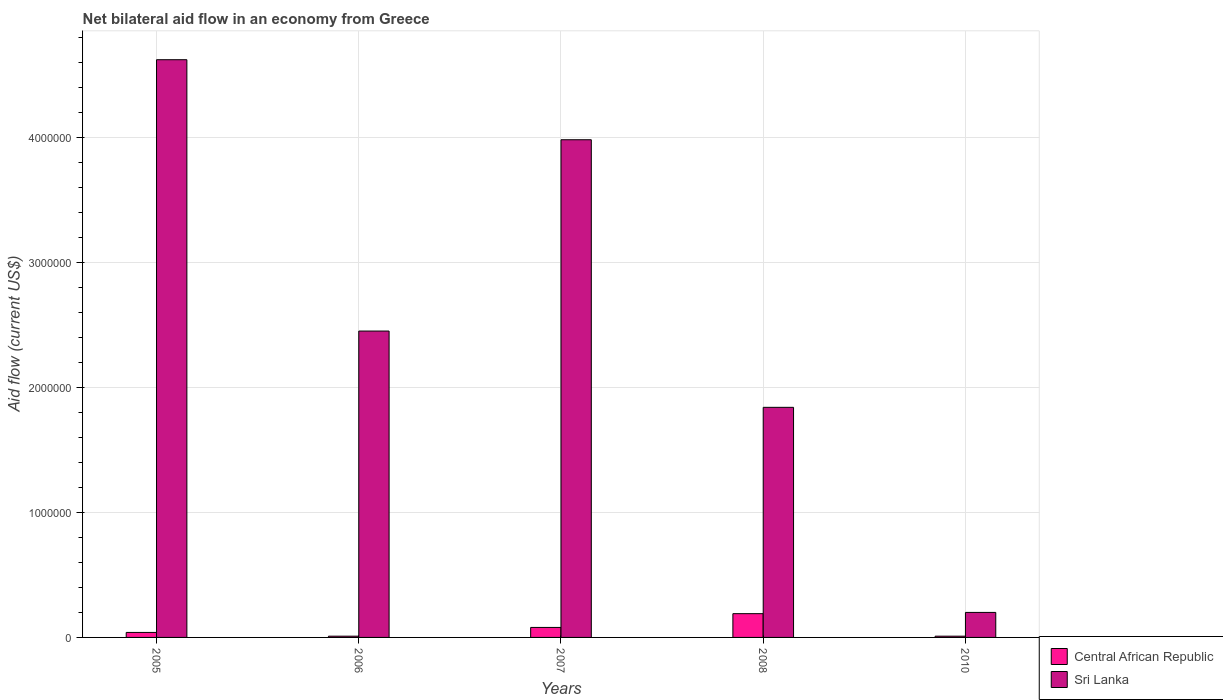How many different coloured bars are there?
Provide a succinct answer. 2. How many groups of bars are there?
Provide a succinct answer. 5. Are the number of bars per tick equal to the number of legend labels?
Keep it short and to the point. Yes. How many bars are there on the 4th tick from the right?
Offer a very short reply. 2. What is the label of the 2nd group of bars from the left?
Make the answer very short. 2006. Across all years, what is the minimum net bilateral aid flow in Central African Republic?
Ensure brevity in your answer.  10000. In which year was the net bilateral aid flow in Sri Lanka maximum?
Your answer should be compact. 2005. In which year was the net bilateral aid flow in Central African Republic minimum?
Keep it short and to the point. 2006. What is the total net bilateral aid flow in Sri Lanka in the graph?
Give a very brief answer. 1.31e+07. What is the difference between the net bilateral aid flow in Central African Republic in 2005 and that in 2008?
Make the answer very short. -1.50e+05. What is the average net bilateral aid flow in Central African Republic per year?
Ensure brevity in your answer.  6.60e+04. In the year 2007, what is the difference between the net bilateral aid flow in Sri Lanka and net bilateral aid flow in Central African Republic?
Make the answer very short. 3.90e+06. What is the difference between the highest and the second highest net bilateral aid flow in Sri Lanka?
Your answer should be very brief. 6.40e+05. In how many years, is the net bilateral aid flow in Sri Lanka greater than the average net bilateral aid flow in Sri Lanka taken over all years?
Provide a short and direct response. 2. What does the 1st bar from the left in 2008 represents?
Ensure brevity in your answer.  Central African Republic. What does the 1st bar from the right in 2006 represents?
Your answer should be very brief. Sri Lanka. How many bars are there?
Your answer should be compact. 10. What is the difference between two consecutive major ticks on the Y-axis?
Provide a succinct answer. 1.00e+06. Are the values on the major ticks of Y-axis written in scientific E-notation?
Keep it short and to the point. No. How many legend labels are there?
Make the answer very short. 2. What is the title of the graph?
Keep it short and to the point. Net bilateral aid flow in an economy from Greece. Does "Ireland" appear as one of the legend labels in the graph?
Offer a very short reply. No. What is the Aid flow (current US$) of Central African Republic in 2005?
Offer a very short reply. 4.00e+04. What is the Aid flow (current US$) of Sri Lanka in 2005?
Offer a terse response. 4.62e+06. What is the Aid flow (current US$) of Central African Republic in 2006?
Provide a succinct answer. 10000. What is the Aid flow (current US$) of Sri Lanka in 2006?
Your response must be concise. 2.45e+06. What is the Aid flow (current US$) of Central African Republic in 2007?
Your response must be concise. 8.00e+04. What is the Aid flow (current US$) of Sri Lanka in 2007?
Make the answer very short. 3.98e+06. What is the Aid flow (current US$) in Central African Republic in 2008?
Ensure brevity in your answer.  1.90e+05. What is the Aid flow (current US$) of Sri Lanka in 2008?
Offer a terse response. 1.84e+06. What is the Aid flow (current US$) in Sri Lanka in 2010?
Provide a short and direct response. 2.00e+05. Across all years, what is the maximum Aid flow (current US$) in Central African Republic?
Offer a terse response. 1.90e+05. Across all years, what is the maximum Aid flow (current US$) of Sri Lanka?
Provide a short and direct response. 4.62e+06. What is the total Aid flow (current US$) in Sri Lanka in the graph?
Offer a terse response. 1.31e+07. What is the difference between the Aid flow (current US$) in Central African Republic in 2005 and that in 2006?
Offer a terse response. 3.00e+04. What is the difference between the Aid flow (current US$) in Sri Lanka in 2005 and that in 2006?
Make the answer very short. 2.17e+06. What is the difference between the Aid flow (current US$) in Central African Republic in 2005 and that in 2007?
Your answer should be very brief. -4.00e+04. What is the difference between the Aid flow (current US$) in Sri Lanka in 2005 and that in 2007?
Keep it short and to the point. 6.40e+05. What is the difference between the Aid flow (current US$) in Sri Lanka in 2005 and that in 2008?
Your response must be concise. 2.78e+06. What is the difference between the Aid flow (current US$) of Central African Republic in 2005 and that in 2010?
Provide a short and direct response. 3.00e+04. What is the difference between the Aid flow (current US$) of Sri Lanka in 2005 and that in 2010?
Your answer should be very brief. 4.42e+06. What is the difference between the Aid flow (current US$) of Sri Lanka in 2006 and that in 2007?
Keep it short and to the point. -1.53e+06. What is the difference between the Aid flow (current US$) of Central African Republic in 2006 and that in 2008?
Offer a terse response. -1.80e+05. What is the difference between the Aid flow (current US$) of Central African Republic in 2006 and that in 2010?
Offer a terse response. 0. What is the difference between the Aid flow (current US$) of Sri Lanka in 2006 and that in 2010?
Your response must be concise. 2.25e+06. What is the difference between the Aid flow (current US$) in Sri Lanka in 2007 and that in 2008?
Provide a succinct answer. 2.14e+06. What is the difference between the Aid flow (current US$) in Central African Republic in 2007 and that in 2010?
Provide a succinct answer. 7.00e+04. What is the difference between the Aid flow (current US$) in Sri Lanka in 2007 and that in 2010?
Give a very brief answer. 3.78e+06. What is the difference between the Aid flow (current US$) in Central African Republic in 2008 and that in 2010?
Provide a succinct answer. 1.80e+05. What is the difference between the Aid flow (current US$) of Sri Lanka in 2008 and that in 2010?
Ensure brevity in your answer.  1.64e+06. What is the difference between the Aid flow (current US$) of Central African Republic in 2005 and the Aid flow (current US$) of Sri Lanka in 2006?
Make the answer very short. -2.41e+06. What is the difference between the Aid flow (current US$) of Central African Republic in 2005 and the Aid flow (current US$) of Sri Lanka in 2007?
Offer a terse response. -3.94e+06. What is the difference between the Aid flow (current US$) in Central African Republic in 2005 and the Aid flow (current US$) in Sri Lanka in 2008?
Ensure brevity in your answer.  -1.80e+06. What is the difference between the Aid flow (current US$) of Central African Republic in 2005 and the Aid flow (current US$) of Sri Lanka in 2010?
Give a very brief answer. -1.60e+05. What is the difference between the Aid flow (current US$) in Central African Republic in 2006 and the Aid flow (current US$) in Sri Lanka in 2007?
Your answer should be very brief. -3.97e+06. What is the difference between the Aid flow (current US$) in Central African Republic in 2006 and the Aid flow (current US$) in Sri Lanka in 2008?
Your answer should be compact. -1.83e+06. What is the difference between the Aid flow (current US$) of Central African Republic in 2006 and the Aid flow (current US$) of Sri Lanka in 2010?
Your answer should be compact. -1.90e+05. What is the difference between the Aid flow (current US$) in Central African Republic in 2007 and the Aid flow (current US$) in Sri Lanka in 2008?
Your answer should be compact. -1.76e+06. What is the difference between the Aid flow (current US$) of Central African Republic in 2007 and the Aid flow (current US$) of Sri Lanka in 2010?
Offer a terse response. -1.20e+05. What is the difference between the Aid flow (current US$) in Central African Republic in 2008 and the Aid flow (current US$) in Sri Lanka in 2010?
Provide a short and direct response. -10000. What is the average Aid flow (current US$) of Central African Republic per year?
Make the answer very short. 6.60e+04. What is the average Aid flow (current US$) of Sri Lanka per year?
Give a very brief answer. 2.62e+06. In the year 2005, what is the difference between the Aid flow (current US$) in Central African Republic and Aid flow (current US$) in Sri Lanka?
Give a very brief answer. -4.58e+06. In the year 2006, what is the difference between the Aid flow (current US$) in Central African Republic and Aid flow (current US$) in Sri Lanka?
Offer a terse response. -2.44e+06. In the year 2007, what is the difference between the Aid flow (current US$) in Central African Republic and Aid flow (current US$) in Sri Lanka?
Ensure brevity in your answer.  -3.90e+06. In the year 2008, what is the difference between the Aid flow (current US$) in Central African Republic and Aid flow (current US$) in Sri Lanka?
Give a very brief answer. -1.65e+06. In the year 2010, what is the difference between the Aid flow (current US$) in Central African Republic and Aid flow (current US$) in Sri Lanka?
Offer a terse response. -1.90e+05. What is the ratio of the Aid flow (current US$) of Sri Lanka in 2005 to that in 2006?
Offer a very short reply. 1.89. What is the ratio of the Aid flow (current US$) of Sri Lanka in 2005 to that in 2007?
Your response must be concise. 1.16. What is the ratio of the Aid flow (current US$) in Central African Republic in 2005 to that in 2008?
Your answer should be very brief. 0.21. What is the ratio of the Aid flow (current US$) in Sri Lanka in 2005 to that in 2008?
Your response must be concise. 2.51. What is the ratio of the Aid flow (current US$) in Central African Republic in 2005 to that in 2010?
Your answer should be compact. 4. What is the ratio of the Aid flow (current US$) of Sri Lanka in 2005 to that in 2010?
Provide a short and direct response. 23.1. What is the ratio of the Aid flow (current US$) of Sri Lanka in 2006 to that in 2007?
Your response must be concise. 0.62. What is the ratio of the Aid flow (current US$) in Central African Republic in 2006 to that in 2008?
Provide a succinct answer. 0.05. What is the ratio of the Aid flow (current US$) of Sri Lanka in 2006 to that in 2008?
Make the answer very short. 1.33. What is the ratio of the Aid flow (current US$) in Central African Republic in 2006 to that in 2010?
Offer a very short reply. 1. What is the ratio of the Aid flow (current US$) in Sri Lanka in 2006 to that in 2010?
Your answer should be very brief. 12.25. What is the ratio of the Aid flow (current US$) of Central African Republic in 2007 to that in 2008?
Ensure brevity in your answer.  0.42. What is the ratio of the Aid flow (current US$) of Sri Lanka in 2007 to that in 2008?
Offer a terse response. 2.16. What is the ratio of the Aid flow (current US$) of Central African Republic in 2007 to that in 2010?
Provide a short and direct response. 8. What is the ratio of the Aid flow (current US$) of Sri Lanka in 2007 to that in 2010?
Give a very brief answer. 19.9. What is the ratio of the Aid flow (current US$) of Central African Republic in 2008 to that in 2010?
Your answer should be compact. 19. What is the difference between the highest and the second highest Aid flow (current US$) in Sri Lanka?
Your answer should be very brief. 6.40e+05. What is the difference between the highest and the lowest Aid flow (current US$) in Central African Republic?
Offer a very short reply. 1.80e+05. What is the difference between the highest and the lowest Aid flow (current US$) in Sri Lanka?
Your answer should be compact. 4.42e+06. 